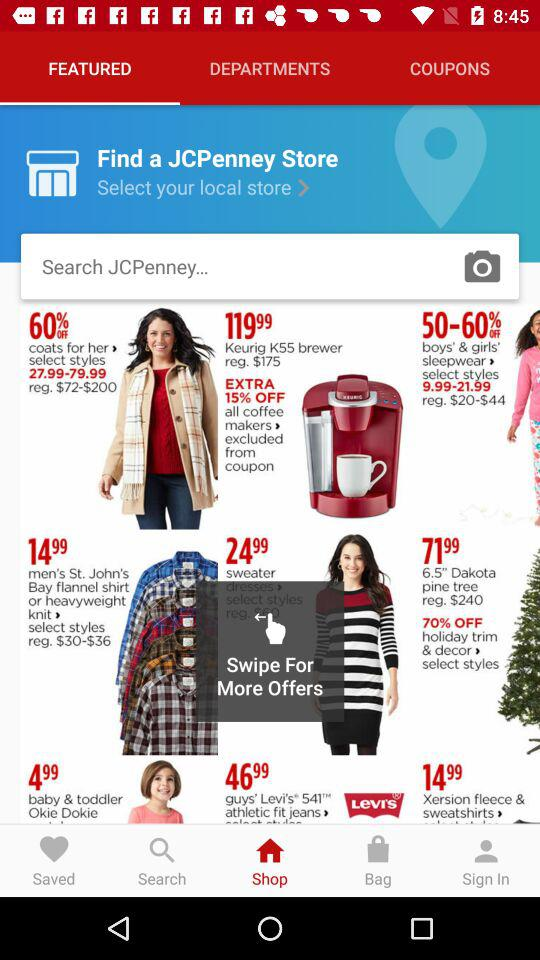What is the price of a Dakota pine tree? The price of a Dakota pine tree is $71.99. 